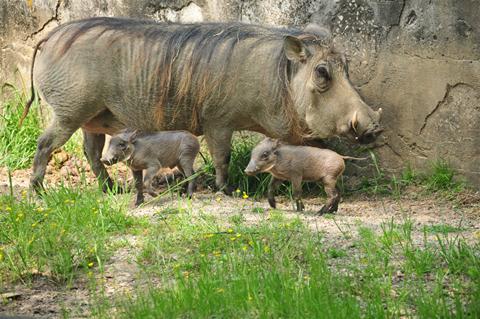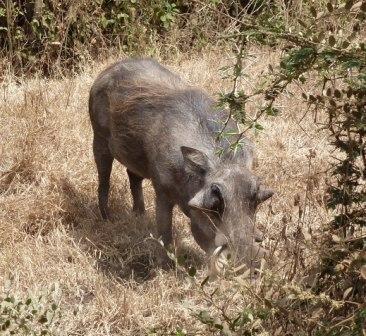The first image is the image on the left, the second image is the image on the right. Examine the images to the left and right. Is the description "The combined images show four warthogs and do not show any other mammal." accurate? Answer yes or no. Yes. The first image is the image on the left, the second image is the image on the right. Examine the images to the left and right. Is the description "A hog and two baby hogs are grazing in the left picture." accurate? Answer yes or no. Yes. 